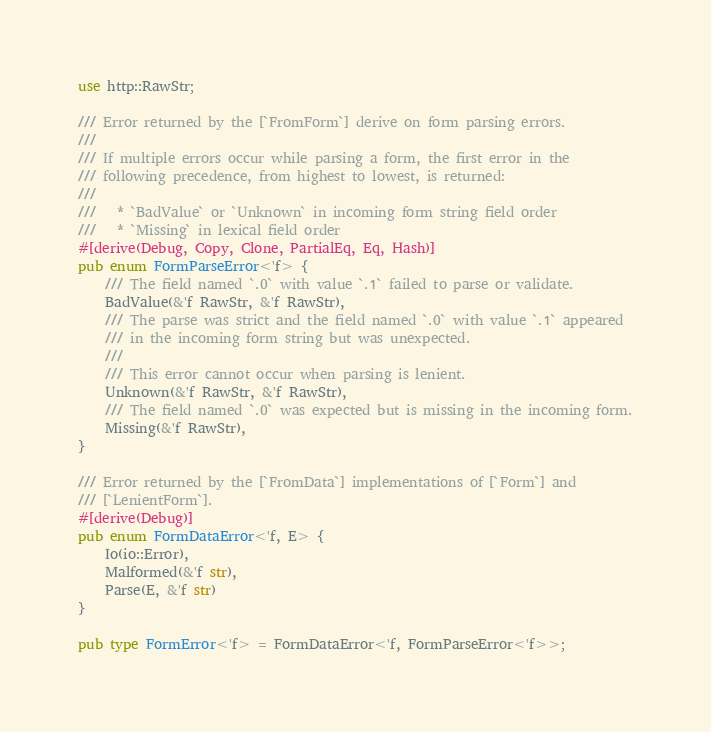Convert code to text. <code><loc_0><loc_0><loc_500><loc_500><_Rust_>use http::RawStr;

/// Error returned by the [`FromForm`] derive on form parsing errors.
///
/// If multiple errors occur while parsing a form, the first error in the
/// following precedence, from highest to lowest, is returned:
///
///   * `BadValue` or `Unknown` in incoming form string field order
///   * `Missing` in lexical field order
#[derive(Debug, Copy, Clone, PartialEq, Eq, Hash)]
pub enum FormParseError<'f> {
    /// The field named `.0` with value `.1` failed to parse or validate.
    BadValue(&'f RawStr, &'f RawStr),
    /// The parse was strict and the field named `.0` with value `.1` appeared
    /// in the incoming form string but was unexpected.
    ///
    /// This error cannot occur when parsing is lenient.
    Unknown(&'f RawStr, &'f RawStr),
    /// The field named `.0` was expected but is missing in the incoming form.
    Missing(&'f RawStr),
}

/// Error returned by the [`FromData`] implementations of [`Form`] and
/// [`LenientForm`].
#[derive(Debug)]
pub enum FormDataError<'f, E> {
    Io(io::Error),
    Malformed(&'f str),
    Parse(E, &'f str)
}

pub type FormError<'f> = FormDataError<'f, FormParseError<'f>>;
</code> 